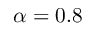Convert formula to latex. <formula><loc_0><loc_0><loc_500><loc_500>\alpha = 0 . 8</formula> 